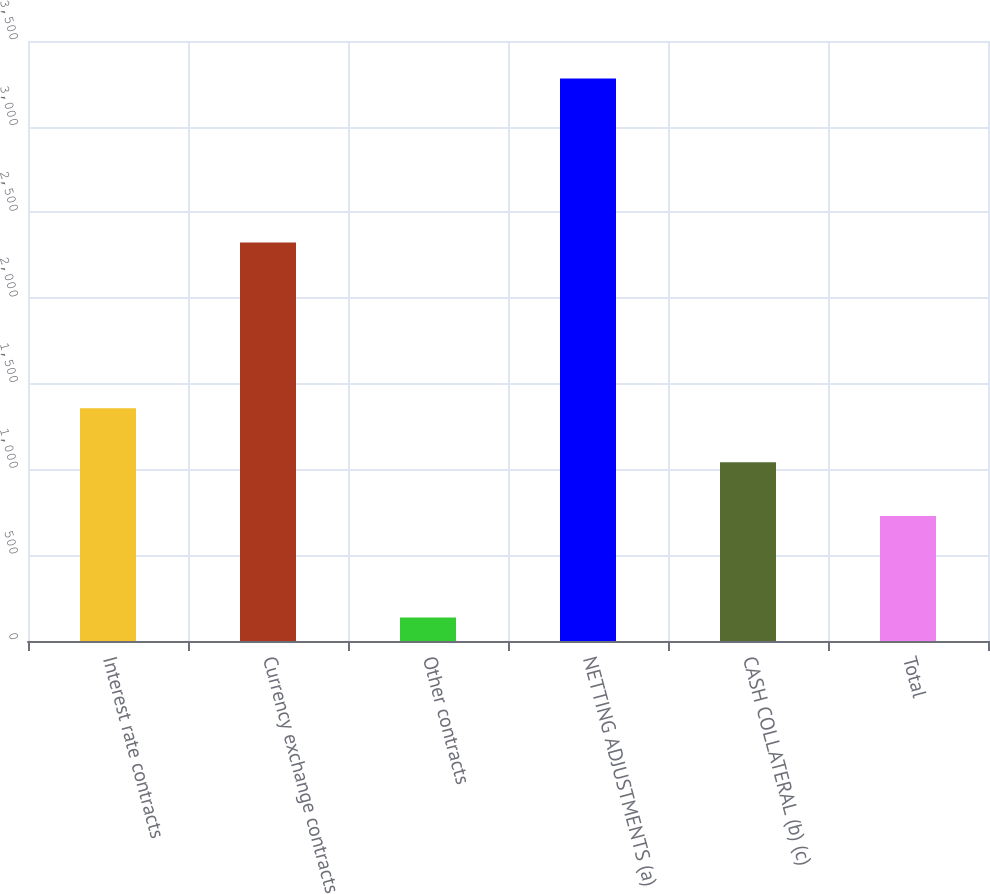Convert chart. <chart><loc_0><loc_0><loc_500><loc_500><bar_chart><fcel>Interest rate contracts<fcel>Currency exchange contracts<fcel>Other contracts<fcel>NETTING ADJUSTMENTS (a)<fcel>CASH COLLATERAL (b) (c)<fcel>Total<nl><fcel>1357.8<fcel>2325<fcel>137<fcel>3281<fcel>1043.4<fcel>729<nl></chart> 